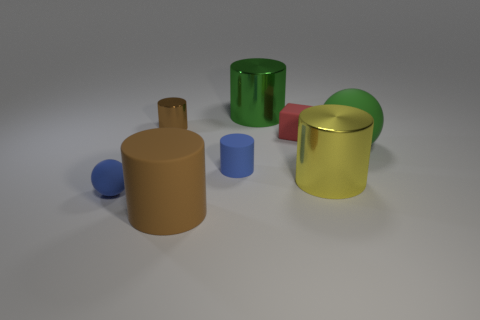Can you tell me what objects are visible on the left side of the image? On the left side, you can see two cylindrical objects, one is taller with a brown tone and the other is shorter and blue. Additionally, there's a small blue sphere. 